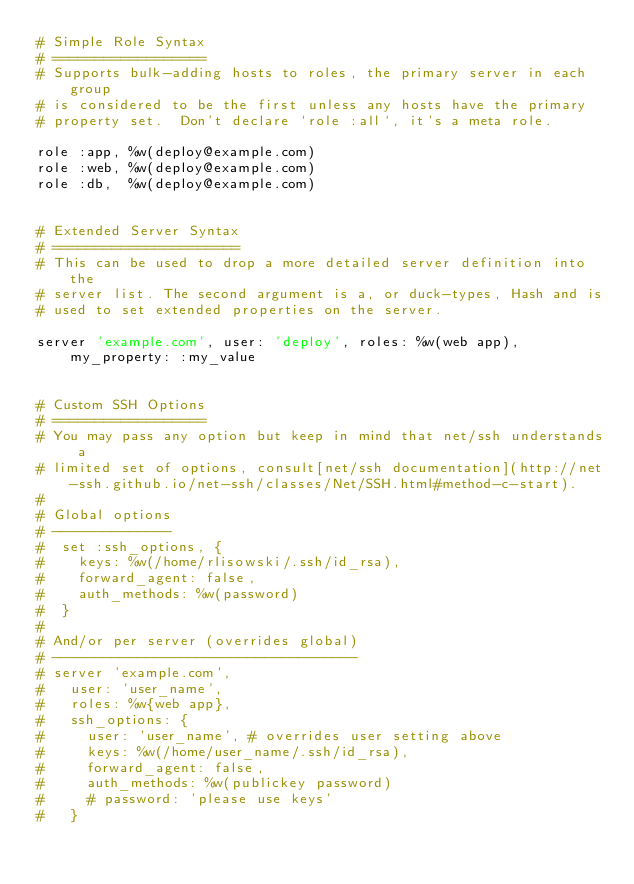<code> <loc_0><loc_0><loc_500><loc_500><_Ruby_># Simple Role Syntax
# ==================
# Supports bulk-adding hosts to roles, the primary server in each group
# is considered to be the first unless any hosts have the primary
# property set.  Don't declare `role :all`, it's a meta role.

role :app, %w(deploy@example.com)
role :web, %w(deploy@example.com)
role :db,  %w(deploy@example.com)


# Extended Server Syntax
# ======================
# This can be used to drop a more detailed server definition into the
# server list. The second argument is a, or duck-types, Hash and is
# used to set extended properties on the server.

server 'example.com', user: 'deploy', roles: %w(web app), my_property: :my_value


# Custom SSH Options
# ==================
# You may pass any option but keep in mind that net/ssh understands a
# limited set of options, consult[net/ssh documentation](http://net-ssh.github.io/net-ssh/classes/Net/SSH.html#method-c-start).
#
# Global options
# --------------
#  set :ssh_options, {
#    keys: %w(/home/rlisowski/.ssh/id_rsa),
#    forward_agent: false,
#    auth_methods: %w(password)
#  }
#
# And/or per server (overrides global)
# ------------------------------------
# server 'example.com',
#   user: 'user_name',
#   roles: %w{web app},
#   ssh_options: {
#     user: 'user_name', # overrides user setting above
#     keys: %w(/home/user_name/.ssh/id_rsa),
#     forward_agent: false,
#     auth_methods: %w(publickey password)
#     # password: 'please use keys'
#   }
</code> 